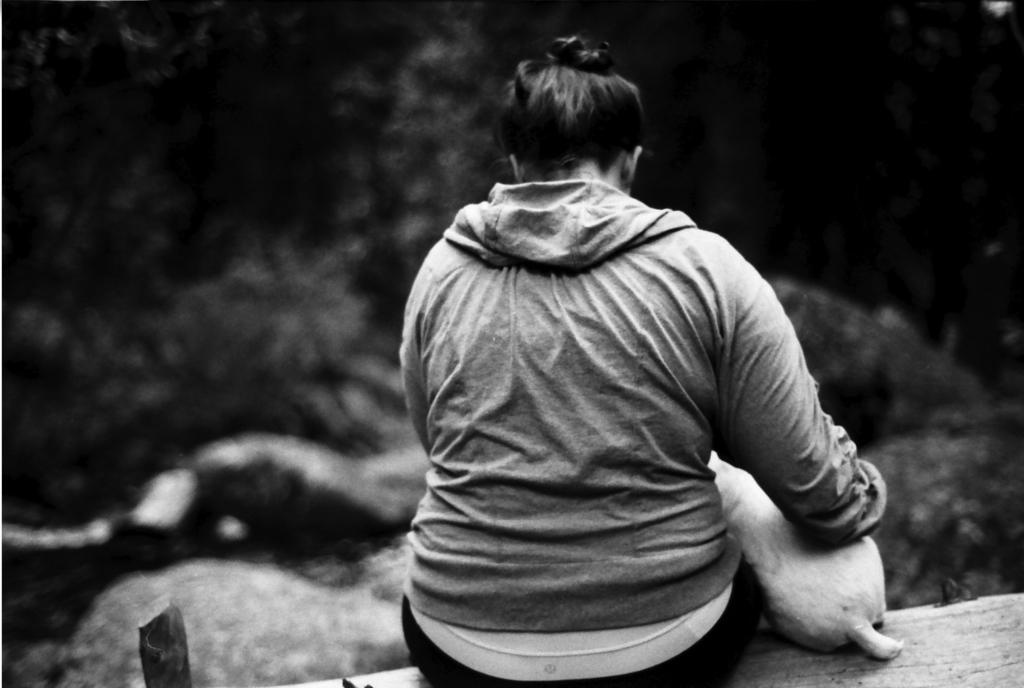What is the person in the image sitting on? The person is sitting on a wooden platform in the image. Is there any other living creature present in the image? Yes, there is a dog beside the person. What can be seen in the background of the image? There are trees in the background of the image. What type of unit can be seen hanging from the trees in the image? There is no unit hanging from the trees in the image; it only features a person sitting on a wooden platform, a dog, and trees in the background. 